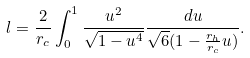Convert formula to latex. <formula><loc_0><loc_0><loc_500><loc_500>l = \frac { 2 } { r _ { c } } \int _ { 0 } ^ { 1 } \frac { u ^ { 2 } } { \sqrt { 1 - u ^ { 4 } } } \frac { d u } { \sqrt { 6 } ( 1 - \frac { r _ { h } } { r _ { c } } u ) } .</formula> 